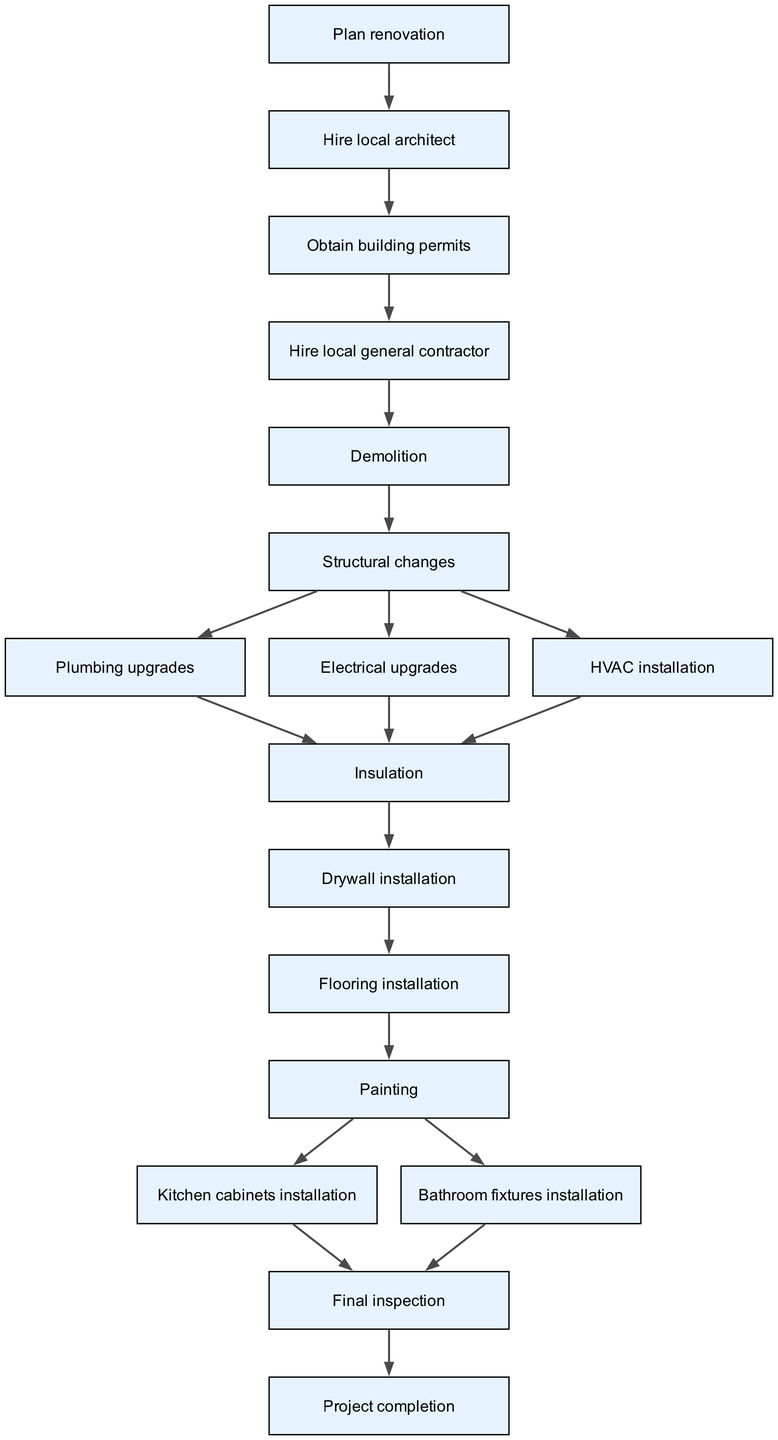What is the first task in the project timeline? The first task in the directed graph is "Plan renovation". It is the initial node from which all other tasks stem.
Answer: Plan renovation How many total tasks are represented in the graph? The graph contains 16 distinct tasks or nodes, as listed in the data provided.
Answer: 16 What task follows "Demolition" in the timeline? The task directly following "Demolition" in the diagram is "Structural changes", as indicated by the directed edge originating from "Demolition".
Answer: Structural changes Which tasks require completion after "Painting"? After "Painting", both "Kitchen cabinets installation" and "Bathroom fixtures installation" are the tasks to complete, indicating parallel tasks that follow the painting.
Answer: Kitchen cabinets installation, Bathroom fixtures installation What is the final task in the project? The final task in the graph is "Project completion", which comes after "Final inspection". It signifies the end of the renovation project timeline.
Answer: Project completion How are plumbing upgrades related to the task before them? "Plumbing upgrades" follow "Structural changes" as a dependent task that requires the completion of structural work before plumbing can be upgraded.
Answer: Structural changes How many edges connect to "Insulation"? Three edges connect to "Insulation", indicating that it is dependent on the completion of "Plumbing upgrades", "Electrical upgrades", and "HVAC installation".
Answer: 3 Which local contractor is hired after obtaining building permits? After obtaining building permits, the "Hire local general contractor" task is the next to follow, indicating the sequence of hiring a contractor.
Answer: Hire local general contractor What two tasks are completed before the "Final inspection"? The "Kitchen cabinets installation" and "Bathroom fixtures installation" need to be completed before the "Final inspection" can occur, as they are both prerequisites listed ahead of it.
Answer: Kitchen cabinets installation, Bathroom fixtures installation 